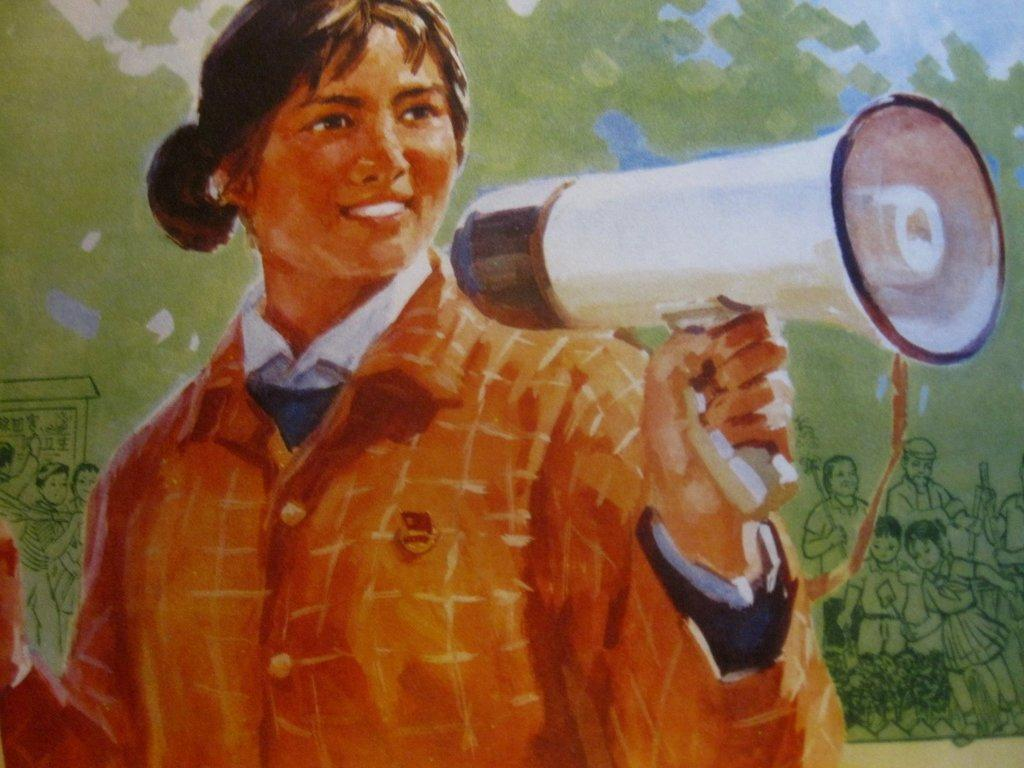What type of artwork is depicted in the image? The image is a painting. Can you describe the main subject of the painting? There is a lady in the center of the painting. What is the lady doing in the painting? The lady is standing and holding a megaphone. What can be seen in the background of the painting? There are people, trees, and the sky visible in the background of the painting. What type of bread can be seen in the lady's hand in the painting? There is no bread present in the lady's hand or in the painting; she is holding a megaphone. What activity are the people in the background of the painting participating in? The provided facts do not mention any specific activity that the people in the background are participating in. 